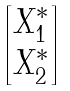<formula> <loc_0><loc_0><loc_500><loc_500>\begin{bmatrix} X _ { 1 } ^ { * } \\ X _ { 2 } ^ { * } \end{bmatrix}</formula> 